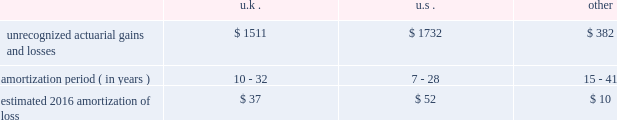Loss on the contract may be recorded , if necessary , and any remaining deferred implementation revenues would typically be recognized over the remaining service period through the termination date .
In connection with our long-term outsourcing service agreements , highly customized implementation efforts are often necessary to set up clients and their human resource or benefit programs on our systems and operating processes .
For outsourcing services sold separately or accounted for as a separate unit of accounting , specific , incremental and direct costs of implementation incurred prior to the services commencing are generally deferred and amortized over the period that the related ongoing services revenue is recognized .
Deferred costs are assessed for recoverability on a periodic basis to the extent the deferred cost exceeds related deferred revenue .
Pensions we sponsor defined benefit pension plans throughout the world .
Our most significant plans are located in the u.s. , the u.k. , the netherlands and canada .
Our significant u.s. , u.k. , netherlands and canadian pension plans are closed to new entrants .
We have ceased crediting future benefits relating to salary and service for our u.s. , u.k. , netherlands and canadian plans to the extent statutorily permitted .
In 2016 , we estimate pension and post-retirement net periodic benefit cost for major plans to increase by $ 15 million to a benefit of approximately $ 54 million .
The increase in the benefit is primarily due to a change in our approach to measuring service and interest cost .
Effective december 31 , 2015 and for 2016 expense , we have elected to utilize a full yield curve approach in the estimation of the service and interest cost components of net periodic pension and post-retirement benefit cost for our major pension and other post-retirement benefit plans by applying the specific spot rates along the yield curve used in the determination of the benefit obligation to the relevant projected cash flows .
In 2015 and prior years , we estimated these components of net periodic pension and post-retirement benefit cost by applying a single weighted-average discount rate , derived from the yield curve used to measure the benefit obligation at the beginning of the period .
We have made this change to improve the correlation between projected benefit cash flows and the corresponding yield curve spot rates and to provide a more precise measurement of service and interest costs .
This change does not affect the measurement of the projected benefit obligation as the change in the service cost and interest cost is completely offset in the actuarial ( gain ) loss recorded in other comprehensive income .
We accounted for this change as a change in estimate and , accordingly , will account for it prospectively .
Recognition of gains and losses and prior service certain changes in the value of the obligation and in the value of plan assets , which may occur due to various factors such as changes in the discount rate and actuarial assumptions , actual demographic experience and/or plan asset performance are not immediately recognized in net income .
Such changes are recognized in other comprehensive income and are amortized into net income as part of the net periodic benefit cost .
Unrecognized gains and losses that have been deferred in other comprehensive income , as previously described , are amortized into compensation and benefits expense as a component of periodic pension expense based on the average life expectancy of the u.s. , the netherlands , canada , and u.k .
Plan members .
We amortize any prior service expense or credits that arise as a result of plan changes over a period consistent with the amortization of gains and losses .
As of december 31 , 2015 , our pension plans have deferred losses that have not yet been recognized through income in the consolidated financial statements .
We amortize unrecognized actuarial losses outside of a corridor , which is defined as 10% ( 10 % ) of the greater of market-related value of plan assets or projected benefit obligation .
To the extent not offset by future gains , incremental amortization as calculated above will continue to affect future pension expense similarly until fully amortized .
The table discloses our unrecognized actuarial gains and losses , the number of years over which we are amortizing the experience loss , and the estimated 2016 amortization of loss by country ( amounts in millions ) : .
The unrecognized prior service cost ( income ) at december 31 , 2015 was $ 9 million , $ 46 million , and $ ( 7 ) million in the u.s. , u.k .
And other plans , respectively .
For the u.s .
Pension plans we use a market-related valuation of assets approach to determine the expected return on assets , which is a component of net periodic benefit cost recognized in the consolidated statements of income .
This approach .
What is the total estimated amortization loss for 2016? 
Computations: ((37 + 52) + 10)
Answer: 99.0. 